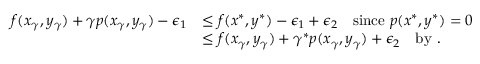<formula> <loc_0><loc_0><loc_500><loc_500>\begin{array} { r l } { f ( x _ { \gamma } , y _ { \gamma } ) + \gamma p ( x _ { \gamma } , y _ { \gamma } ) - \epsilon _ { 1 } } & { \leq f ( x ^ { * } , y ^ { * } ) - \epsilon _ { 1 } + \epsilon _ { 2 } \quad \sin c e p ( x ^ { * } , y ^ { * } ) = 0 } \\ & { \leq f ( x _ { \gamma } , y _ { \gamma } ) + \gamma ^ { * } p ( x _ { \gamma } , y _ { \gamma } ) + \epsilon _ { 2 } \quad b y . } \end{array}</formula> 